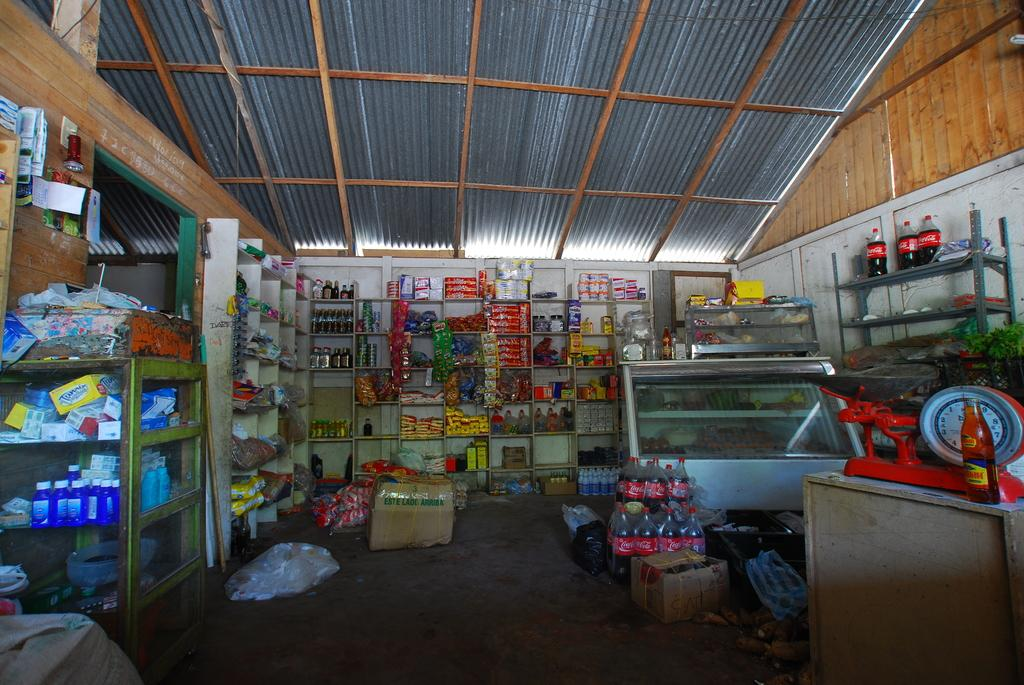<image>
Share a concise interpretation of the image provided. Two litter bottles of Coca Cola are on a shelf in a cluttered room. 